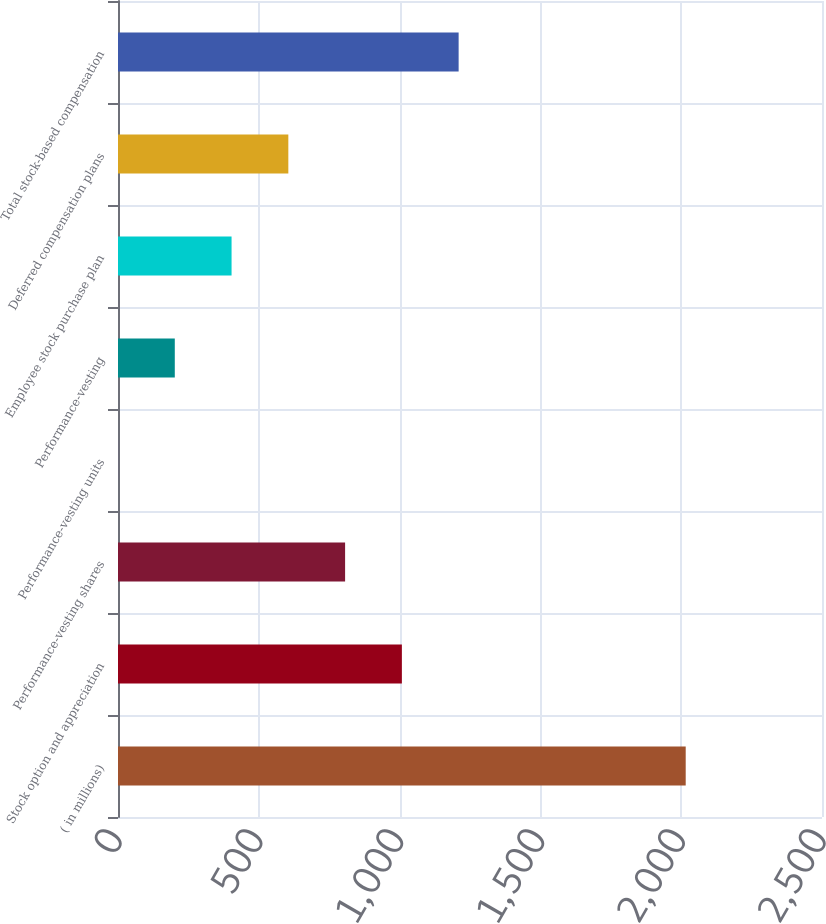Convert chart. <chart><loc_0><loc_0><loc_500><loc_500><bar_chart><fcel>( in millions)<fcel>Stock option and appreciation<fcel>Performance-vesting shares<fcel>Performance-vesting units<fcel>Performance-vesting<fcel>Employee stock purchase plan<fcel>Deferred compensation plans<fcel>Total stock-based compensation<nl><fcel>2016<fcel>1008.05<fcel>806.46<fcel>0.1<fcel>201.69<fcel>403.28<fcel>604.87<fcel>1209.64<nl></chart> 